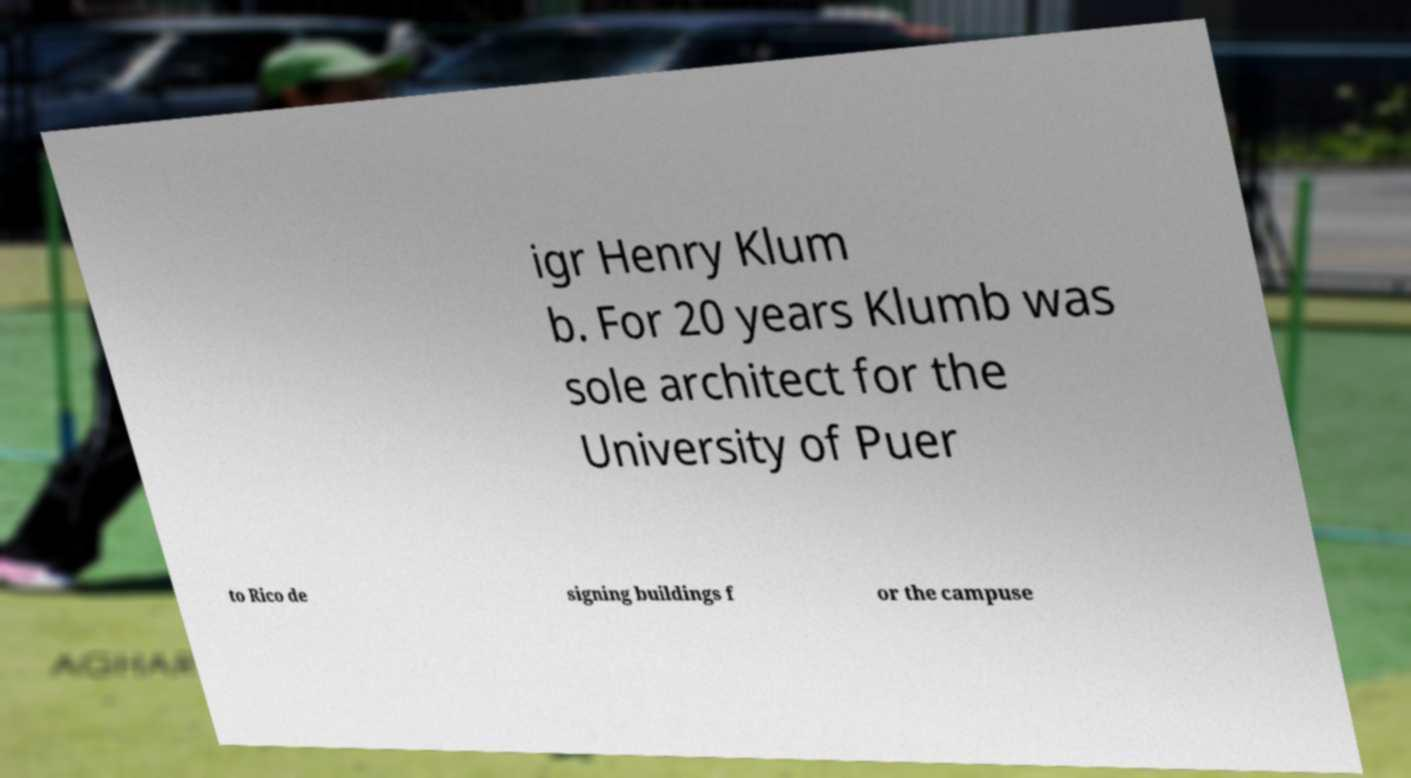There's text embedded in this image that I need extracted. Can you transcribe it verbatim? igr Henry Klum b. For 20 years Klumb was sole architect for the University of Puer to Rico de signing buildings f or the campuse 